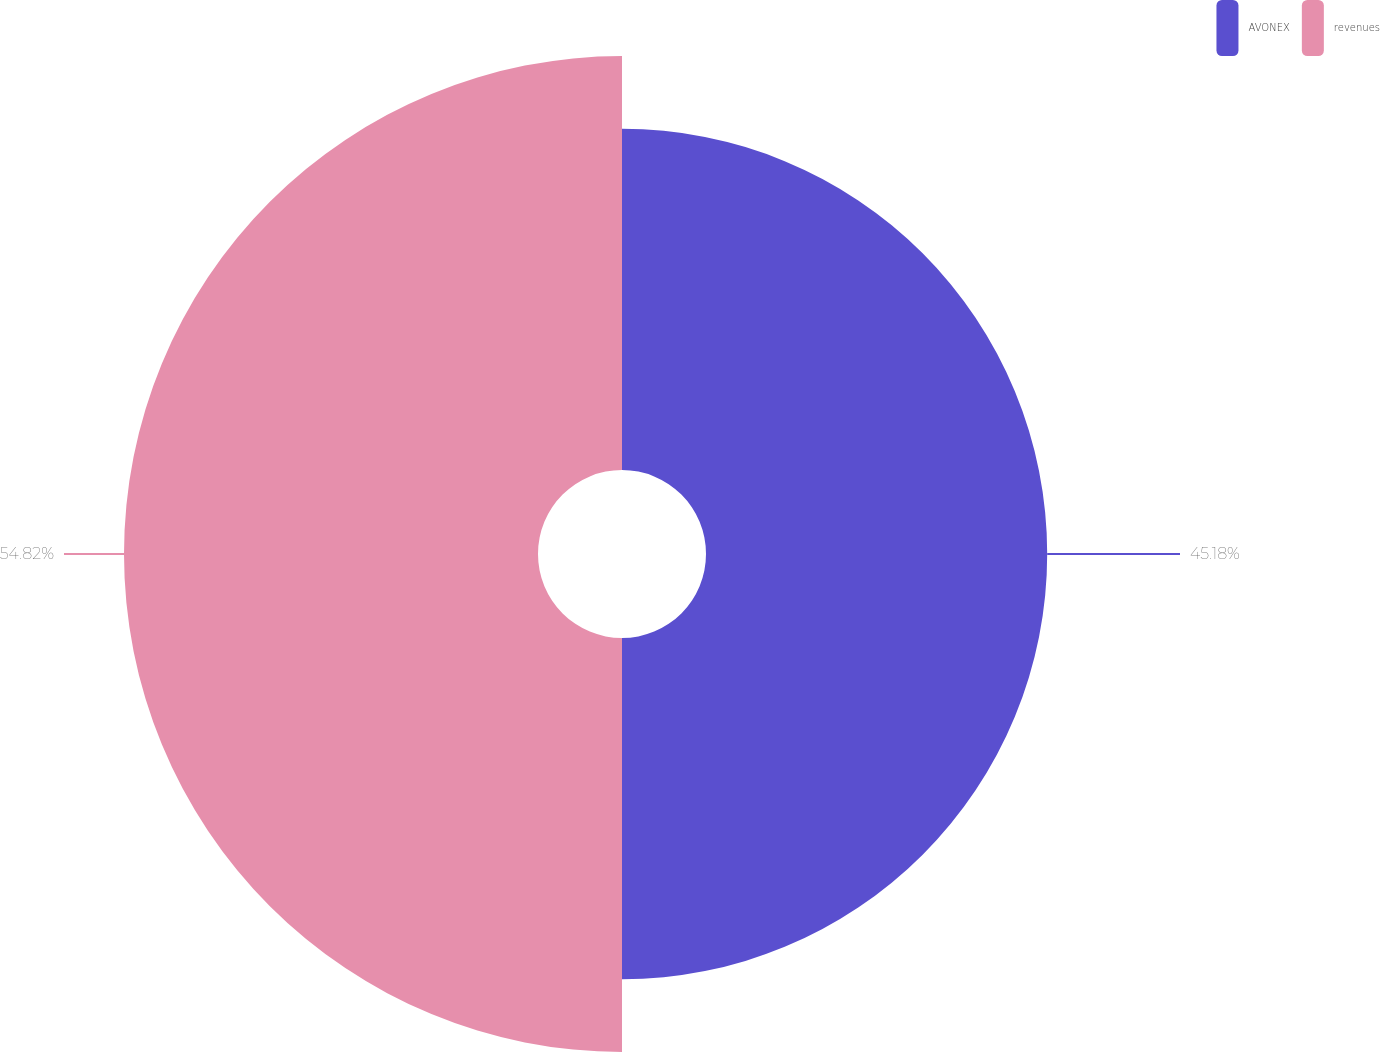<chart> <loc_0><loc_0><loc_500><loc_500><pie_chart><fcel>AVONEX<fcel>revenues<nl><fcel>45.18%<fcel>54.82%<nl></chart> 